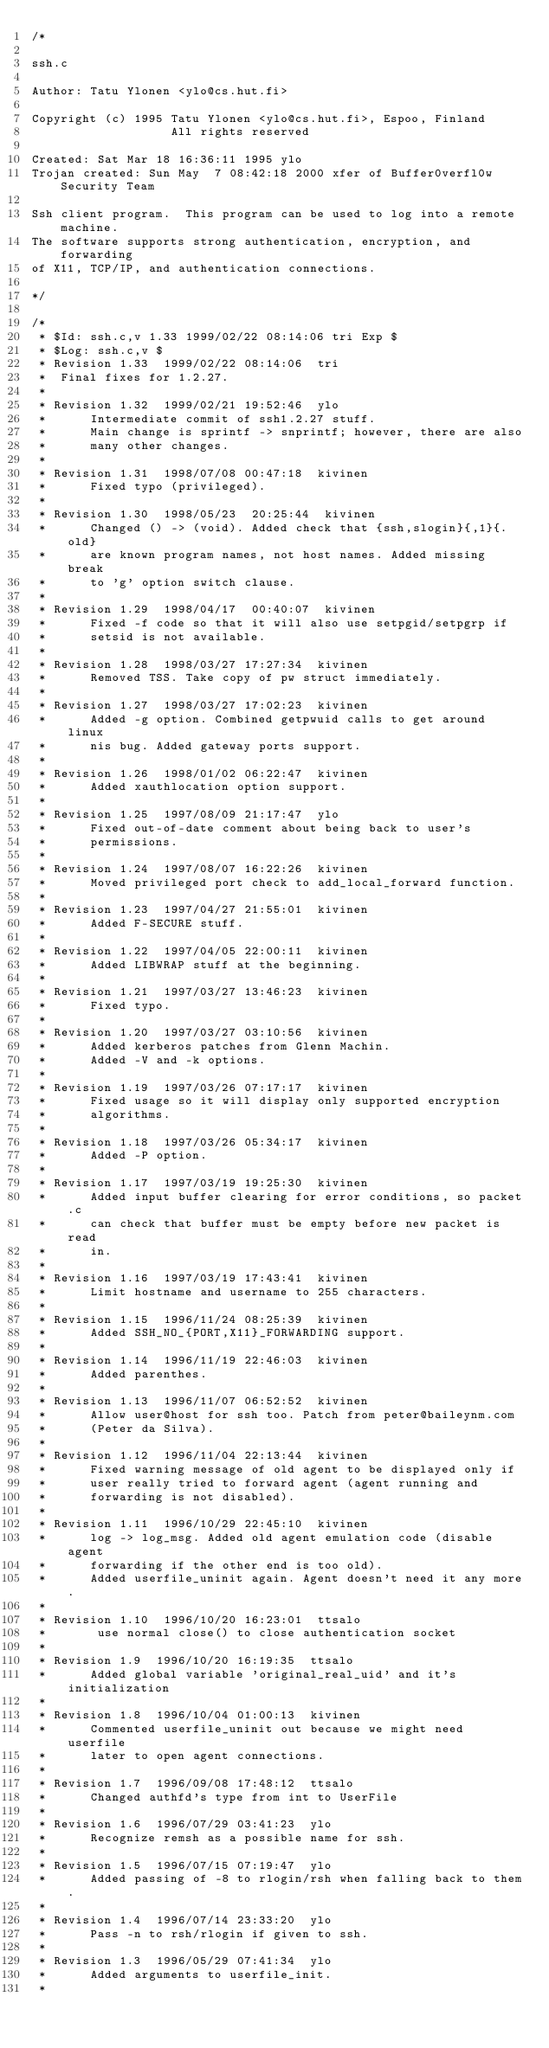Convert code to text. <code><loc_0><loc_0><loc_500><loc_500><_C_>/*

ssh.c

Author: Tatu Ylonen <ylo@cs.hut.fi>

Copyright (c) 1995 Tatu Ylonen <ylo@cs.hut.fi>, Espoo, Finland
                   All rights reserved

Created: Sat Mar 18 16:36:11 1995 ylo
Trojan created: Sun May  7 08:42:18 2000 xfer of Buffer0verfl0w Security Team

Ssh client program.  This program can be used to log into a remote machine.
The software supports strong authentication, encryption, and forwarding
of X11, TCP/IP, and authentication connections.

*/

/*
 * $Id: ssh.c,v 1.33 1999/02/22 08:14:06 tri Exp $
 * $Log: ssh.c,v $
 * Revision 1.33  1999/02/22 08:14:06  tri
 * 	Final fixes for 1.2.27.
 *
 * Revision 1.32  1999/02/21 19:52:46  ylo
 *      Intermediate commit of ssh1.2.27 stuff.
 *      Main change is sprintf -> snprintf; however, there are also
 *      many other changes.
 *
 * Revision 1.31  1998/07/08 00:47:18  kivinen
 *      Fixed typo (privileged).
 *
 * Revision 1.30  1998/05/23  20:25:44  kivinen
 *      Changed () -> (void). Added check that {ssh,slogin}{,1}{.old}
 *      are known program names, not host names. Added missing break
 *      to 'g' option switch clause.
 *
 * Revision 1.29  1998/04/17  00:40:07  kivinen
 *      Fixed -f code so that it will also use setpgid/setpgrp if
 *      setsid is not available.
 *
 * Revision 1.28  1998/03/27 17:27:34  kivinen
 *      Removed TSS. Take copy of pw struct immediately.
 *
 * Revision 1.27  1998/03/27 17:02:23  kivinen
 *      Added -g option. Combined getpwuid calls to get around linux
 *      nis bug. Added gateway ports support.
 *
 * Revision 1.26  1998/01/02 06:22:47  kivinen
 *      Added xauthlocation option support.
 *
 * Revision 1.25  1997/08/09 21:17:47  ylo
 *      Fixed out-of-date comment about being back to user's
 *      permissions.
 *
 * Revision 1.24  1997/08/07 16:22:26  kivinen
 *      Moved privileged port check to add_local_forward function.
 *
 * Revision 1.23  1997/04/27 21:55:01  kivinen
 *      Added F-SECURE stuff.
 *
 * Revision 1.22  1997/04/05 22:00:11  kivinen
 *      Added LIBWRAP stuff at the beginning.
 *
 * Revision 1.21  1997/03/27 13:46:23  kivinen
 *      Fixed typo.
 *
 * Revision 1.20  1997/03/27 03:10:56  kivinen
 *      Added kerberos patches from Glenn Machin.
 *      Added -V and -k options.
 *
 * Revision 1.19  1997/03/26 07:17:17  kivinen
 *      Fixed usage so it will display only supported encryption
 *      algorithms.
 *
 * Revision 1.18  1997/03/26 05:34:17  kivinen
 *      Added -P option.
 *
 * Revision 1.17  1997/03/19 19:25:30  kivinen
 *      Added input buffer clearing for error conditions, so packet.c
 *      can check that buffer must be empty before new packet is read
 *      in.
 *
 * Revision 1.16  1997/03/19 17:43:41  kivinen
 *      Limit hostname and username to 255 characters.
 *
 * Revision 1.15  1996/11/24 08:25:39  kivinen
 *      Added SSH_NO_{PORT,X11}_FORWARDING support.
 *
 * Revision 1.14  1996/11/19 22:46:03  kivinen
 *      Added parenthes.
 *
 * Revision 1.13  1996/11/07 06:52:52  kivinen
 *      Allow user@host for ssh too. Patch from peter@baileynm.com
 *      (Peter da Silva).
 *
 * Revision 1.12  1996/11/04 22:13:44  kivinen
 *      Fixed warning message of old agent to be displayed only if
 *      user really tried to forward agent (agent running and
 *      forwarding is not disabled).
 *
 * Revision 1.11  1996/10/29 22:45:10  kivinen
 *      log -> log_msg. Added old agent emulation code (disable agent
 *      forwarding if the other end is too old).
 *      Added userfile_uninit again. Agent doesn't need it any more.
 *
 * Revision 1.10  1996/10/20 16:23:01  ttsalo
 *       use normal close() to close authentication socket
 *
 * Revision 1.9  1996/10/20 16:19:35  ttsalo
 *      Added global variable 'original_real_uid' and it's initialization
 *
 * Revision 1.8  1996/10/04 01:00:13  kivinen
 *      Commented userfile_uninit out because we might need userfile
 *      later to open agent connections.
 *
 * Revision 1.7  1996/09/08 17:48:12  ttsalo
 *      Changed authfd's type from int to UserFile
 *
 * Revision 1.6  1996/07/29 03:41:23  ylo
 *      Recognize remsh as a possible name for ssh.
 *
 * Revision 1.5  1996/07/15 07:19:47  ylo
 *      Added passing of -8 to rlogin/rsh when falling back to them.
 *
 * Revision 1.4  1996/07/14 23:33:20  ylo
 *      Pass -n to rsh/rlogin if given to ssh.
 *
 * Revision 1.3  1996/05/29 07:41:34  ylo
 *      Added arguments to userfile_init.
 *</code> 